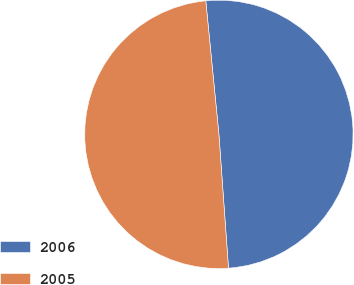Convert chart. <chart><loc_0><loc_0><loc_500><loc_500><pie_chart><fcel>2006<fcel>2005<nl><fcel>50.42%<fcel>49.58%<nl></chart> 